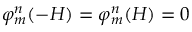Convert formula to latex. <formula><loc_0><loc_0><loc_500><loc_500>\varphi _ { m } ^ { n } ( - H ) = \varphi _ { m } ^ { n } ( H ) = 0</formula> 